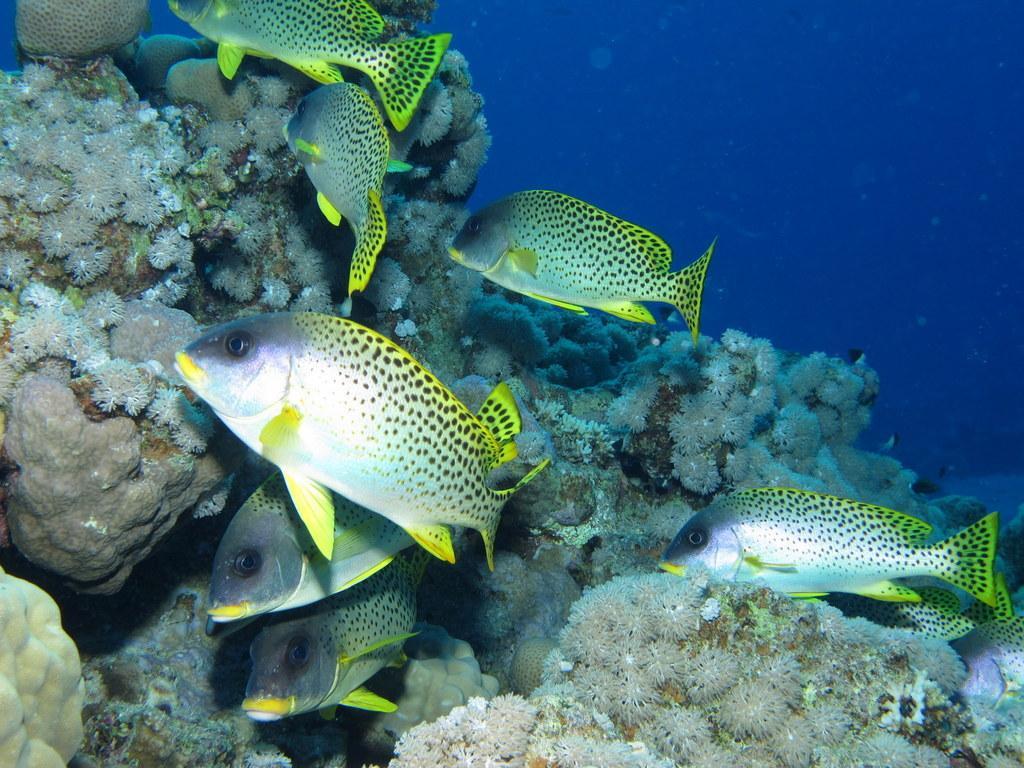How would you summarize this image in a sentence or two? In this image we can see fishes in water. 